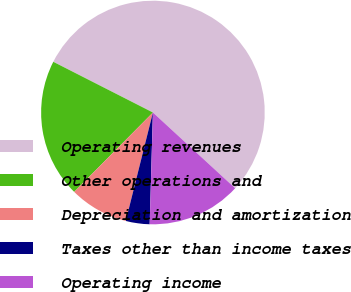Convert chart. <chart><loc_0><loc_0><loc_500><loc_500><pie_chart><fcel>Operating revenues<fcel>Other operations and<fcel>Depreciation and amortization<fcel>Taxes other than income taxes<fcel>Operating income<nl><fcel>54.35%<fcel>20.06%<fcel>8.53%<fcel>3.44%<fcel>13.62%<nl></chart> 